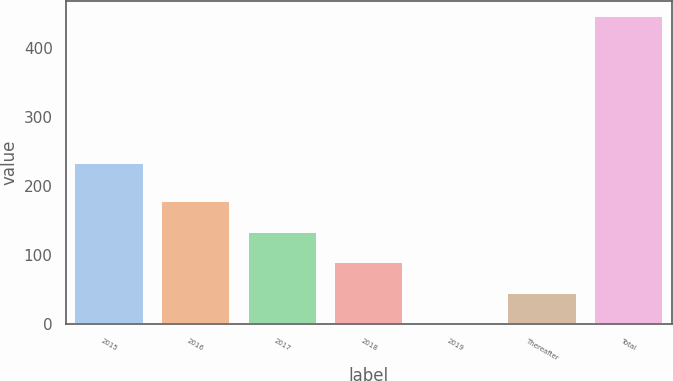Convert chart. <chart><loc_0><loc_0><loc_500><loc_500><bar_chart><fcel>2015<fcel>2016<fcel>2017<fcel>2018<fcel>2019<fcel>Thereafter<fcel>Total<nl><fcel>234<fcel>179<fcel>134.5<fcel>90<fcel>1<fcel>45.5<fcel>446<nl></chart> 